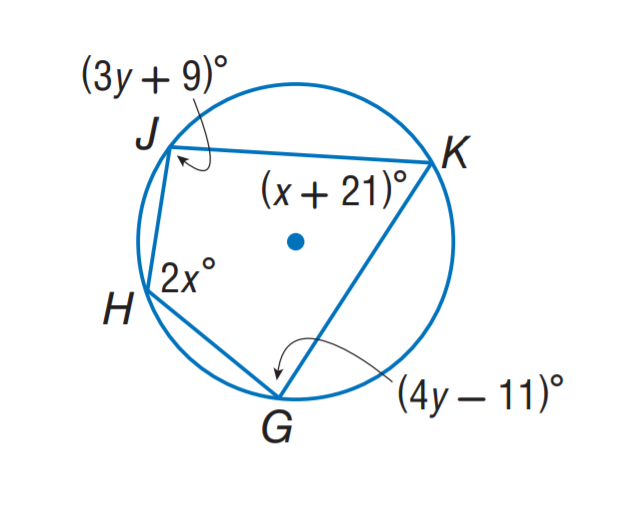Answer the mathemtical geometry problem and directly provide the correct option letter.
Question: Find m \angle H.
Choices: A: 93 B: 97 C: 106 D: 116 C 